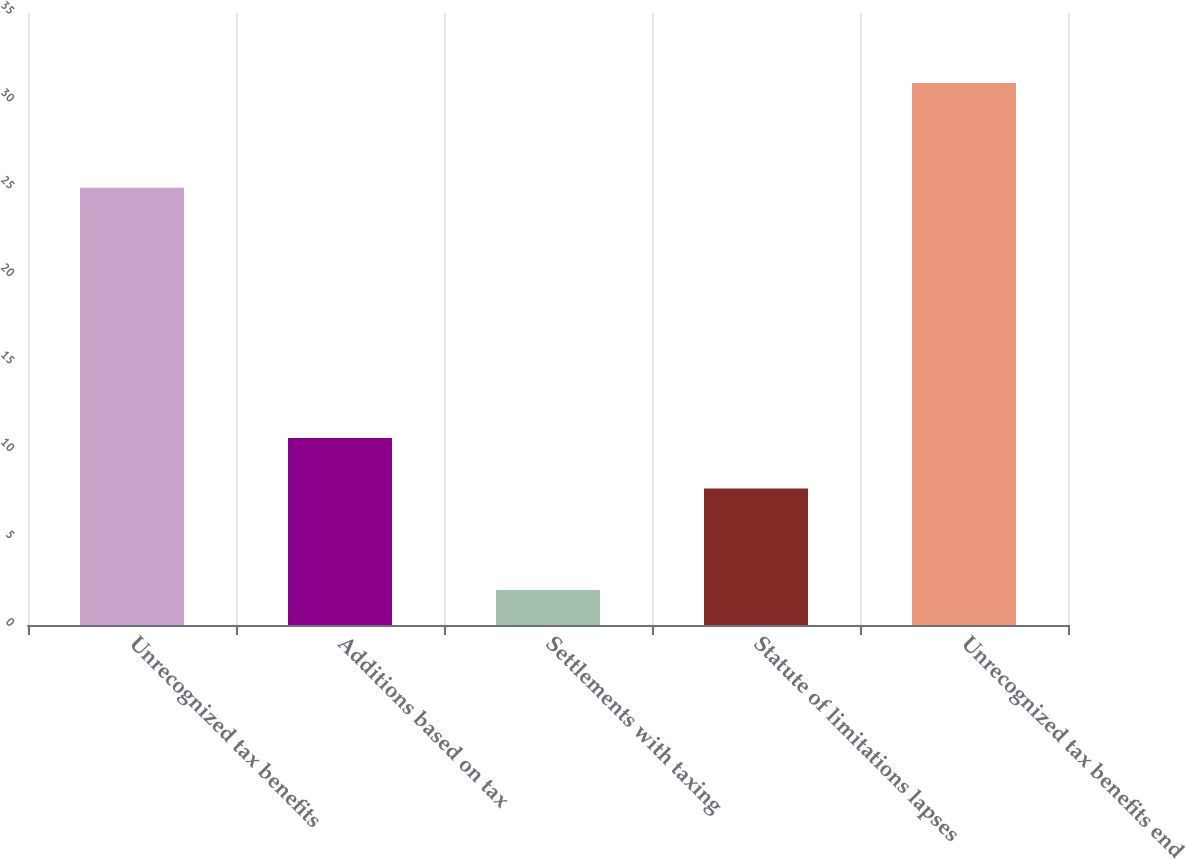Convert chart to OTSL. <chart><loc_0><loc_0><loc_500><loc_500><bar_chart><fcel>Unrecognized tax benefits<fcel>Additions based on tax<fcel>Settlements with taxing<fcel>Statute of limitations lapses<fcel>Unrecognized tax benefits end<nl><fcel>25<fcel>10.7<fcel>2<fcel>7.8<fcel>31<nl></chart> 